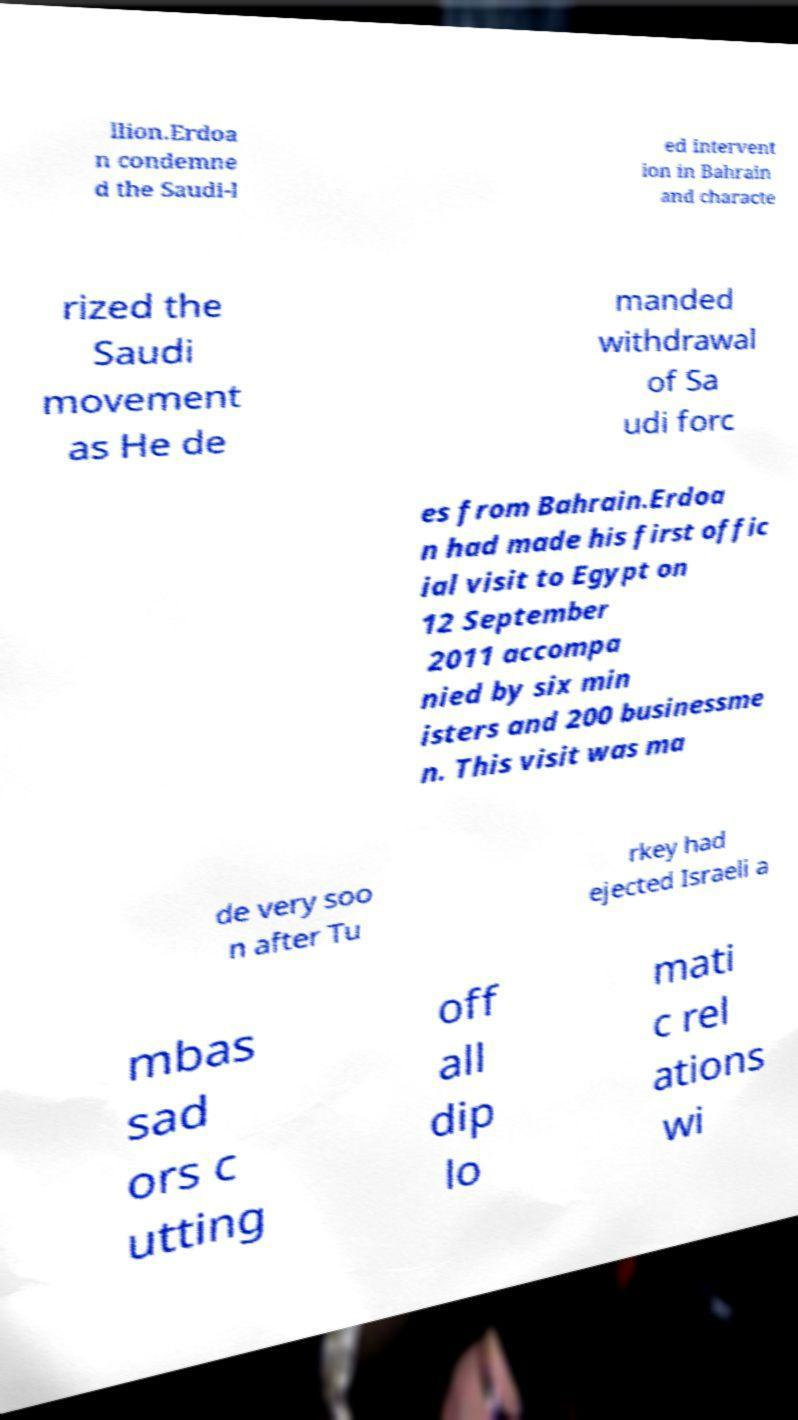I need the written content from this picture converted into text. Can you do that? llion.Erdoa n condemne d the Saudi-l ed intervent ion in Bahrain and characte rized the Saudi movement as He de manded withdrawal of Sa udi forc es from Bahrain.Erdoa n had made his first offic ial visit to Egypt on 12 September 2011 accompa nied by six min isters and 200 businessme n. This visit was ma de very soo n after Tu rkey had ejected Israeli a mbas sad ors c utting off all dip lo mati c rel ations wi 